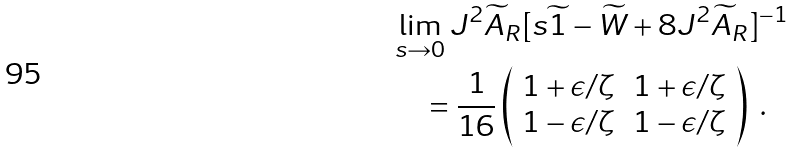Convert formula to latex. <formula><loc_0><loc_0><loc_500><loc_500>& \lim _ { s \rightarrow 0 } J ^ { 2 } \widetilde { A } _ { R } [ s \widetilde { 1 } - \widetilde { W } + 8 J ^ { 2 } \widetilde { A } _ { R } ] ^ { - 1 } \\ & \quad = \frac { 1 } { 1 6 } \left ( \begin{array} { c c } 1 + \epsilon / \zeta & 1 + \epsilon / \zeta \\ 1 - \epsilon / \zeta & 1 - \epsilon / \zeta \end{array} \right ) \ .</formula> 